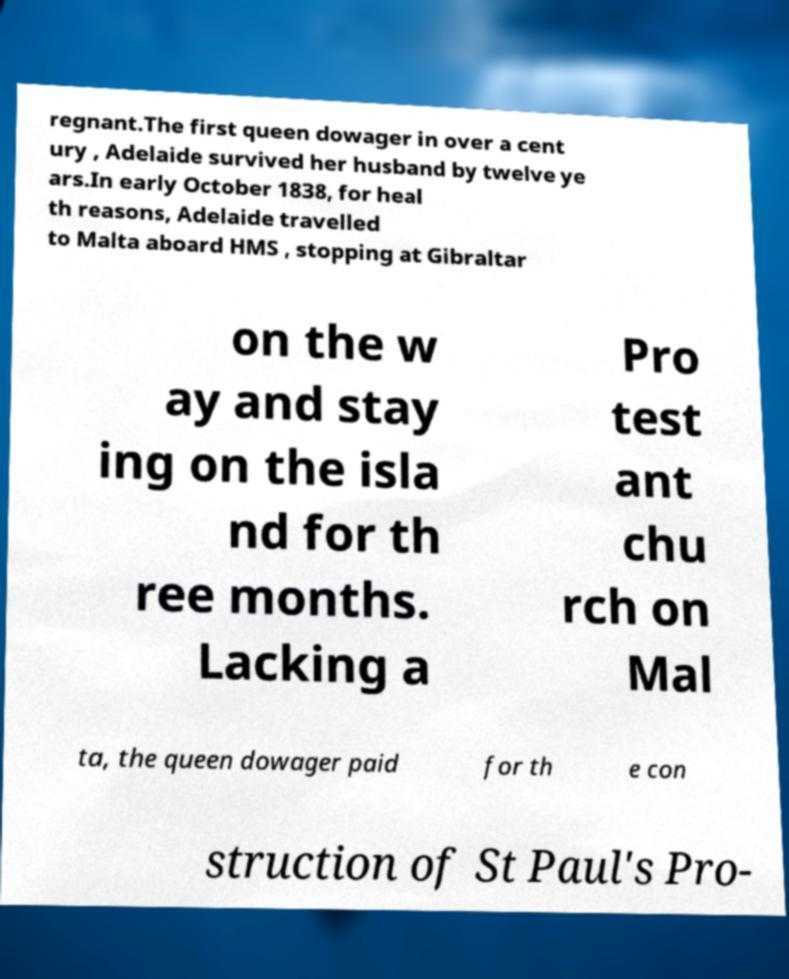Can you read and provide the text displayed in the image?This photo seems to have some interesting text. Can you extract and type it out for me? regnant.The first queen dowager in over a cent ury , Adelaide survived her husband by twelve ye ars.In early October 1838, for heal th reasons, Adelaide travelled to Malta aboard HMS , stopping at Gibraltar on the w ay and stay ing on the isla nd for th ree months. Lacking a Pro test ant chu rch on Mal ta, the queen dowager paid for th e con struction of St Paul's Pro- 